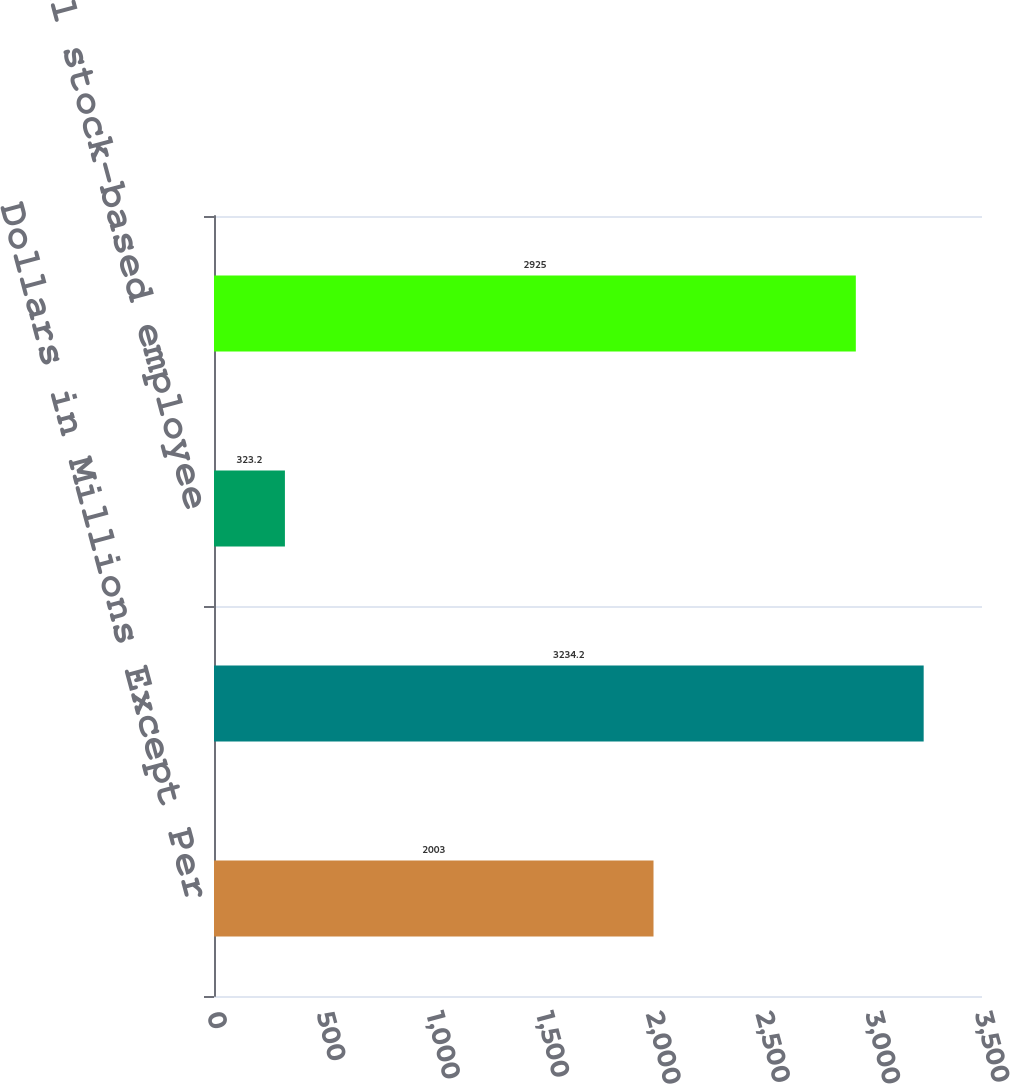Convert chart. <chart><loc_0><loc_0><loc_500><loc_500><bar_chart><fcel>Dollars in Millions Except Per<fcel>As reported<fcel>Total stock-based employee<fcel>Pro forma<nl><fcel>2003<fcel>3234.2<fcel>323.2<fcel>2925<nl></chart> 